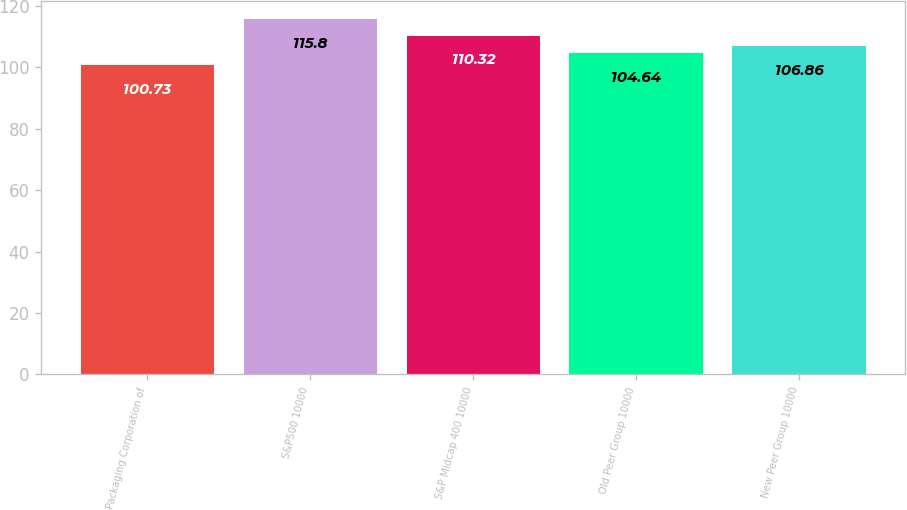Convert chart to OTSL. <chart><loc_0><loc_0><loc_500><loc_500><bar_chart><fcel>Packaging Corporation of<fcel>S&P500 10000<fcel>S&P Midcap 400 10000<fcel>Old Peer Group 10000<fcel>New Peer Group 10000<nl><fcel>100.73<fcel>115.8<fcel>110.32<fcel>104.64<fcel>106.86<nl></chart> 